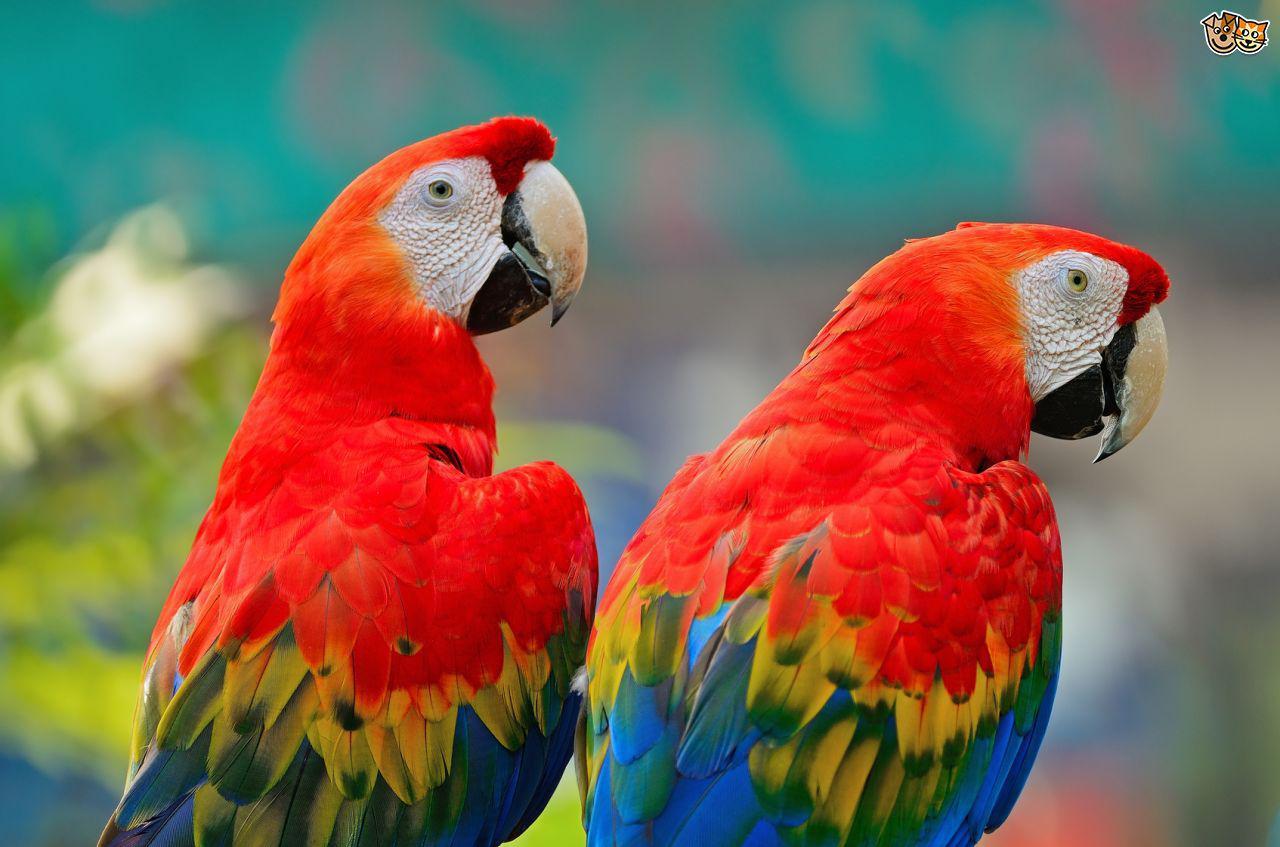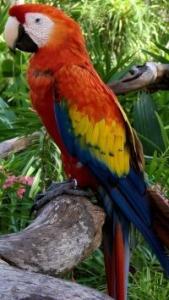The first image is the image on the left, the second image is the image on the right. Assess this claim about the two images: "One of the images contains exactly five birds.". Correct or not? Answer yes or no. No. 